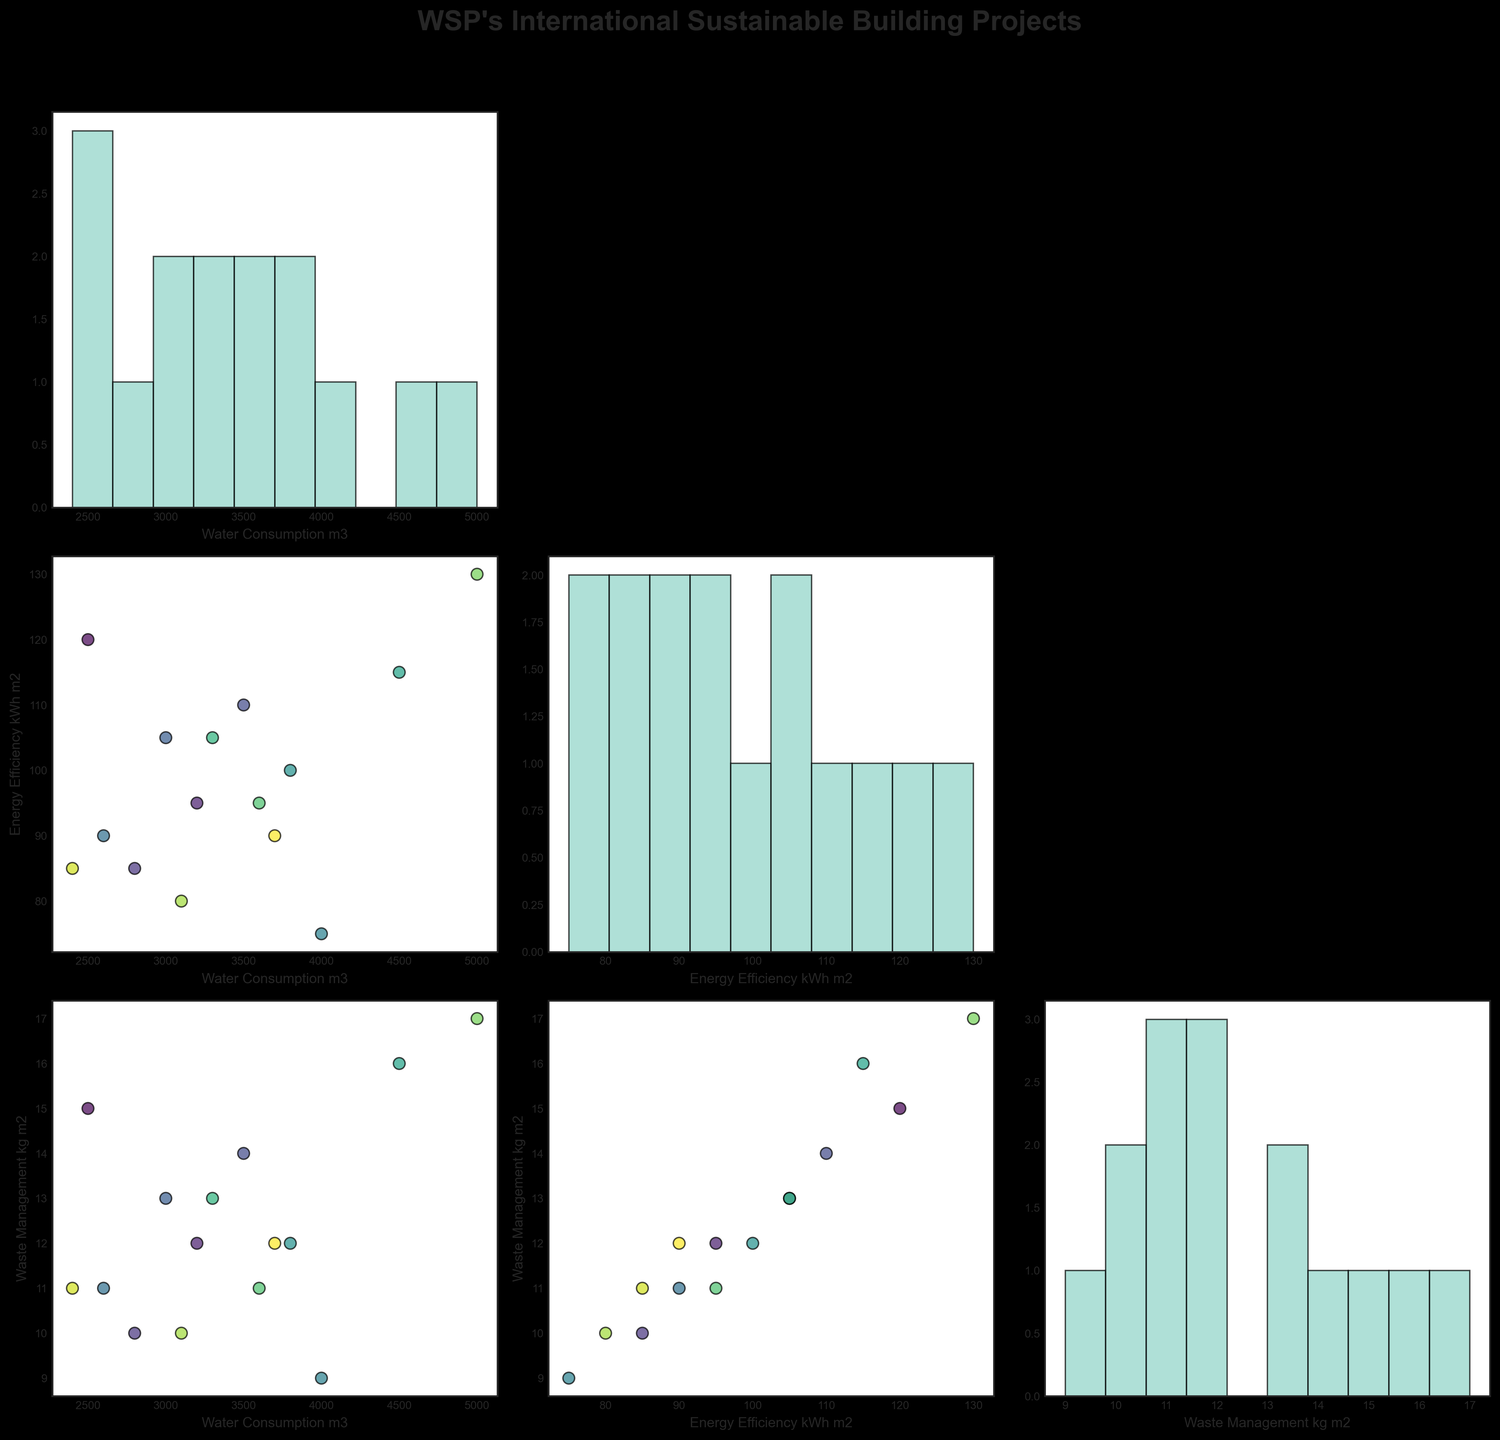What are the variables plotted in the scatterplot matrix? The title mentions that the plot is about WSP's international sustainable building projects. By looking at the axes of the plots in the scatterplot matrix, we can identify "Water Consumption (m3)", "Energy Efficiency (kWh/m2)", and "Waste Management (kg/m2)" as the variables shown.
Answer: Water Consumption, Energy Efficiency, Waste Management Which project has the highest water consumption? In the scatterplot with "Water Consumption (m3)" on the y-axis, we observe the highest data point. Cross-referencing with the project list, "Burj Khalifa" in Dubai has the highest water consumption at 5000 m3.
Answer: Burj Khalifa What is the relationship between Energy Efficiency and Waste Management practices in WSP projects? Observing the scatterplot where "Energy Efficiency (kWh/m2)" is on the x-axis and "Waste Management (kg/m2)" is on the y-axis, we can consider if there's any visible pattern. The scatter of points doesn't clearly show a consistent linear relationship, implying varied practices across projects.
Answer: Varied, no clear linear relationship Which project has the lowest energy efficiency and how does it compare in terms of water consumption? By identifying the lowest value on the "Energy Efficiency (kWh/m2)" axis (which is 75 kWh/m2) and locating the corresponding project ("Shanghai Tower"), we then check the water consumption for this project (4000 m3).
Answer: Shanghai Tower, 4000 m3 What is the average energy efficiency across all projects? To find the average energy efficiency, we sum all the energy efficiency values and divide by the number of projects: (120 + 95 + 85 + 110 + 105 + 90 + 75 + 100 + 115 + 105 + 95 + 130 + 80 + 85 + 90) / 15 = 96.33 kWh/m2.
Answer: 96.33 kWh/m2 Is there any project that lies at an extreme for more than one variable? Examining the plots closely, we see "Burj Khalifa" stands out in both water consumption (highest at 5000 m3) and waste management (highest at 17 kg/m2).
Answer: Burj Khalifa Which two projects manage their waste most efficiently? The scatterplot matrix shows the "Waste Management (kg/m2)" variable, where the lowest values are identified. "Shanghai Tower" and "Salesforce Tower" have the lowest waste management values at 9 kg/m2 and 10 kg/m2 respectively.
Answer: Shanghai Tower and Salesforce Tower How does the "Taipei 101" project compare in "Energy Efficiency" and "Waste Management"? Referencing the scatterplots for "Taipei 101", we see its energy efficiency is 100 kWh/m2 and waste management is 12 kg/m2, which are moderate values in their respective ranges.
Answer: 100 kWh/m2 and 12 kg/m2 